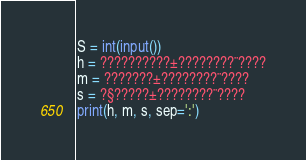Convert code to text. <code><loc_0><loc_0><loc_500><loc_500><_Python_>S = int(input())
h = ??????????±????????¨????
m = ???????±????????¨????
s = ?§?????±????????¨????
print(h, m, s, sep=':')</code> 